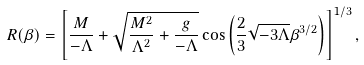<formula> <loc_0><loc_0><loc_500><loc_500>R ( \beta ) = \left [ \frac { M } { - \Lambda } + \sqrt { \frac { M ^ { 2 } } { \Lambda ^ { 2 } } + \frac { g } { - \Lambda } } \cos \left ( \frac { 2 } { 3 } \sqrt { - 3 \Lambda } \beta ^ { 3 / 2 } \right ) \right ] ^ { 1 / 3 } ,</formula> 